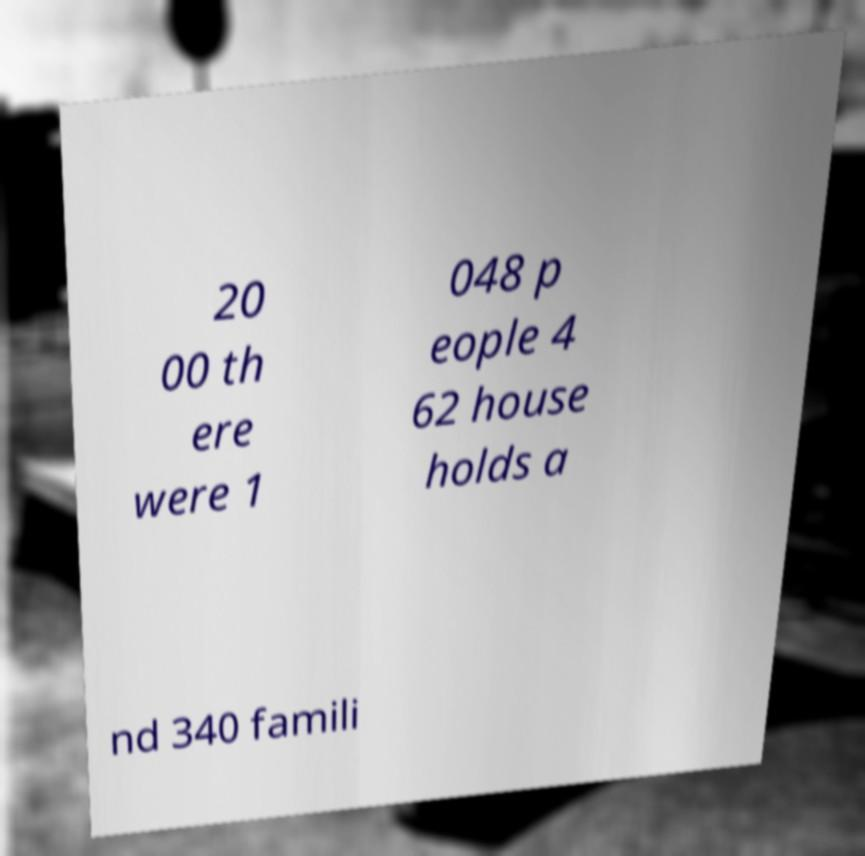Please identify and transcribe the text found in this image. 20 00 th ere were 1 048 p eople 4 62 house holds a nd 340 famili 